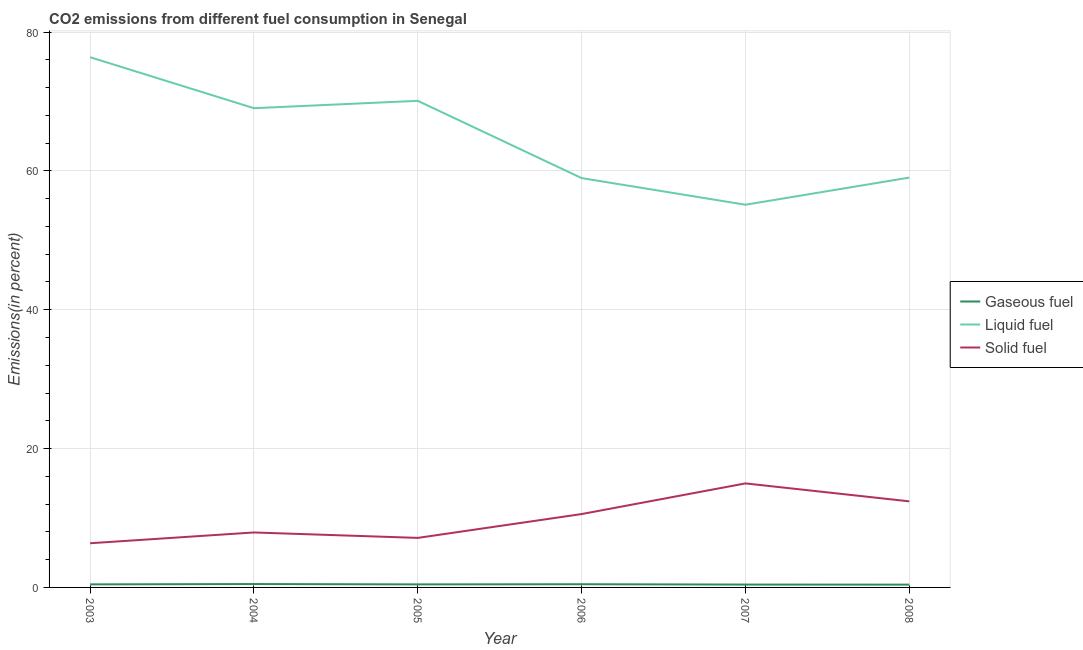Does the line corresponding to percentage of solid fuel emission intersect with the line corresponding to percentage of liquid fuel emission?
Make the answer very short. No. Is the number of lines equal to the number of legend labels?
Your answer should be compact. Yes. What is the percentage of liquid fuel emission in 2007?
Ensure brevity in your answer.  55.12. Across all years, what is the maximum percentage of liquid fuel emission?
Make the answer very short. 76.37. Across all years, what is the minimum percentage of gaseous fuel emission?
Give a very brief answer. 0.4. What is the total percentage of liquid fuel emission in the graph?
Your response must be concise. 388.6. What is the difference between the percentage of gaseous fuel emission in 2004 and that in 2006?
Offer a very short reply. 0.03. What is the difference between the percentage of liquid fuel emission in 2006 and the percentage of solid fuel emission in 2003?
Ensure brevity in your answer.  52.59. What is the average percentage of liquid fuel emission per year?
Give a very brief answer. 64.77. In the year 2006, what is the difference between the percentage of liquid fuel emission and percentage of gaseous fuel emission?
Your response must be concise. 58.5. In how many years, is the percentage of liquid fuel emission greater than 60 %?
Your answer should be compact. 3. What is the ratio of the percentage of gaseous fuel emission in 2005 to that in 2008?
Offer a terse response. 1.08. Is the percentage of gaseous fuel emission in 2004 less than that in 2007?
Your answer should be very brief. No. What is the difference between the highest and the second highest percentage of gaseous fuel emission?
Offer a very short reply. 0.03. What is the difference between the highest and the lowest percentage of liquid fuel emission?
Your response must be concise. 21.25. Are the values on the major ticks of Y-axis written in scientific E-notation?
Offer a very short reply. No. Does the graph contain grids?
Provide a short and direct response. Yes. Where does the legend appear in the graph?
Your answer should be compact. Center right. What is the title of the graph?
Ensure brevity in your answer.  CO2 emissions from different fuel consumption in Senegal. Does "Transport" appear as one of the legend labels in the graph?
Provide a short and direct response. No. What is the label or title of the Y-axis?
Keep it short and to the point. Emissions(in percent). What is the Emissions(in percent) in Gaseous fuel in 2003?
Provide a succinct answer. 0.44. What is the Emissions(in percent) in Liquid fuel in 2003?
Your answer should be compact. 76.37. What is the Emissions(in percent) of Solid fuel in 2003?
Offer a very short reply. 6.36. What is the Emissions(in percent) in Gaseous fuel in 2004?
Provide a succinct answer. 0.49. What is the Emissions(in percent) in Liquid fuel in 2004?
Provide a short and direct response. 69.03. What is the Emissions(in percent) in Solid fuel in 2004?
Make the answer very short. 7.92. What is the Emissions(in percent) in Gaseous fuel in 2005?
Your answer should be very brief. 0.44. What is the Emissions(in percent) in Liquid fuel in 2005?
Offer a terse response. 70.09. What is the Emissions(in percent) of Solid fuel in 2005?
Give a very brief answer. 7.13. What is the Emissions(in percent) of Gaseous fuel in 2006?
Keep it short and to the point. 0.46. What is the Emissions(in percent) in Liquid fuel in 2006?
Offer a terse response. 58.96. What is the Emissions(in percent) of Solid fuel in 2006?
Your answer should be very brief. 10.57. What is the Emissions(in percent) in Gaseous fuel in 2007?
Your answer should be compact. 0.41. What is the Emissions(in percent) in Liquid fuel in 2007?
Provide a short and direct response. 55.12. What is the Emissions(in percent) of Solid fuel in 2007?
Offer a terse response. 14.98. What is the Emissions(in percent) in Gaseous fuel in 2008?
Give a very brief answer. 0.4. What is the Emissions(in percent) in Liquid fuel in 2008?
Give a very brief answer. 59.03. What is the Emissions(in percent) of Solid fuel in 2008?
Your response must be concise. 12.4. Across all years, what is the maximum Emissions(in percent) of Gaseous fuel?
Your answer should be very brief. 0.49. Across all years, what is the maximum Emissions(in percent) in Liquid fuel?
Make the answer very short. 76.37. Across all years, what is the maximum Emissions(in percent) of Solid fuel?
Offer a terse response. 14.98. Across all years, what is the minimum Emissions(in percent) of Gaseous fuel?
Your response must be concise. 0.4. Across all years, what is the minimum Emissions(in percent) of Liquid fuel?
Make the answer very short. 55.12. Across all years, what is the minimum Emissions(in percent) of Solid fuel?
Your answer should be compact. 6.36. What is the total Emissions(in percent) in Gaseous fuel in the graph?
Offer a very short reply. 2.64. What is the total Emissions(in percent) of Liquid fuel in the graph?
Offer a terse response. 388.6. What is the total Emissions(in percent) in Solid fuel in the graph?
Your answer should be compact. 59.36. What is the difference between the Emissions(in percent) in Gaseous fuel in 2003 and that in 2004?
Keep it short and to the point. -0.05. What is the difference between the Emissions(in percent) of Liquid fuel in 2003 and that in 2004?
Your answer should be compact. 7.34. What is the difference between the Emissions(in percent) in Solid fuel in 2003 and that in 2004?
Offer a very short reply. -1.55. What is the difference between the Emissions(in percent) in Gaseous fuel in 2003 and that in 2005?
Give a very brief answer. 0. What is the difference between the Emissions(in percent) in Liquid fuel in 2003 and that in 2005?
Your answer should be compact. 6.28. What is the difference between the Emissions(in percent) of Solid fuel in 2003 and that in 2005?
Keep it short and to the point. -0.77. What is the difference between the Emissions(in percent) in Gaseous fuel in 2003 and that in 2006?
Keep it short and to the point. -0.02. What is the difference between the Emissions(in percent) in Liquid fuel in 2003 and that in 2006?
Keep it short and to the point. 17.41. What is the difference between the Emissions(in percent) of Solid fuel in 2003 and that in 2006?
Ensure brevity in your answer.  -4.2. What is the difference between the Emissions(in percent) in Gaseous fuel in 2003 and that in 2007?
Your response must be concise. 0.03. What is the difference between the Emissions(in percent) in Liquid fuel in 2003 and that in 2007?
Your answer should be very brief. 21.25. What is the difference between the Emissions(in percent) in Solid fuel in 2003 and that in 2007?
Give a very brief answer. -8.62. What is the difference between the Emissions(in percent) in Gaseous fuel in 2003 and that in 2008?
Ensure brevity in your answer.  0.03. What is the difference between the Emissions(in percent) of Liquid fuel in 2003 and that in 2008?
Your answer should be very brief. 17.34. What is the difference between the Emissions(in percent) in Solid fuel in 2003 and that in 2008?
Provide a succinct answer. -6.03. What is the difference between the Emissions(in percent) in Gaseous fuel in 2004 and that in 2005?
Offer a terse response. 0.05. What is the difference between the Emissions(in percent) of Liquid fuel in 2004 and that in 2005?
Give a very brief answer. -1.06. What is the difference between the Emissions(in percent) in Solid fuel in 2004 and that in 2005?
Offer a terse response. 0.78. What is the difference between the Emissions(in percent) in Gaseous fuel in 2004 and that in 2006?
Your answer should be compact. 0.03. What is the difference between the Emissions(in percent) of Liquid fuel in 2004 and that in 2006?
Provide a short and direct response. 10.07. What is the difference between the Emissions(in percent) of Solid fuel in 2004 and that in 2006?
Provide a short and direct response. -2.65. What is the difference between the Emissions(in percent) in Gaseous fuel in 2004 and that in 2007?
Provide a short and direct response. 0.07. What is the difference between the Emissions(in percent) in Liquid fuel in 2004 and that in 2007?
Your response must be concise. 13.91. What is the difference between the Emissions(in percent) in Solid fuel in 2004 and that in 2007?
Give a very brief answer. -7.07. What is the difference between the Emissions(in percent) of Gaseous fuel in 2004 and that in 2008?
Keep it short and to the point. 0.08. What is the difference between the Emissions(in percent) of Liquid fuel in 2004 and that in 2008?
Your response must be concise. 10. What is the difference between the Emissions(in percent) in Solid fuel in 2004 and that in 2008?
Offer a terse response. -4.48. What is the difference between the Emissions(in percent) in Gaseous fuel in 2005 and that in 2006?
Provide a short and direct response. -0.02. What is the difference between the Emissions(in percent) of Liquid fuel in 2005 and that in 2006?
Provide a short and direct response. 11.13. What is the difference between the Emissions(in percent) in Solid fuel in 2005 and that in 2006?
Offer a terse response. -3.43. What is the difference between the Emissions(in percent) in Gaseous fuel in 2005 and that in 2007?
Offer a very short reply. 0.03. What is the difference between the Emissions(in percent) in Liquid fuel in 2005 and that in 2007?
Give a very brief answer. 14.97. What is the difference between the Emissions(in percent) in Solid fuel in 2005 and that in 2007?
Give a very brief answer. -7.85. What is the difference between the Emissions(in percent) of Gaseous fuel in 2005 and that in 2008?
Your answer should be very brief. 0.03. What is the difference between the Emissions(in percent) in Liquid fuel in 2005 and that in 2008?
Ensure brevity in your answer.  11.06. What is the difference between the Emissions(in percent) in Solid fuel in 2005 and that in 2008?
Your response must be concise. -5.26. What is the difference between the Emissions(in percent) in Gaseous fuel in 2006 and that in 2007?
Your response must be concise. 0.05. What is the difference between the Emissions(in percent) of Liquid fuel in 2006 and that in 2007?
Your answer should be very brief. 3.84. What is the difference between the Emissions(in percent) in Solid fuel in 2006 and that in 2007?
Keep it short and to the point. -4.42. What is the difference between the Emissions(in percent) of Gaseous fuel in 2006 and that in 2008?
Provide a succinct answer. 0.06. What is the difference between the Emissions(in percent) of Liquid fuel in 2006 and that in 2008?
Ensure brevity in your answer.  -0.07. What is the difference between the Emissions(in percent) of Solid fuel in 2006 and that in 2008?
Keep it short and to the point. -1.83. What is the difference between the Emissions(in percent) of Gaseous fuel in 2007 and that in 2008?
Provide a succinct answer. 0.01. What is the difference between the Emissions(in percent) in Liquid fuel in 2007 and that in 2008?
Your response must be concise. -3.91. What is the difference between the Emissions(in percent) of Solid fuel in 2007 and that in 2008?
Provide a succinct answer. 2.58. What is the difference between the Emissions(in percent) of Gaseous fuel in 2003 and the Emissions(in percent) of Liquid fuel in 2004?
Ensure brevity in your answer.  -68.59. What is the difference between the Emissions(in percent) of Gaseous fuel in 2003 and the Emissions(in percent) of Solid fuel in 2004?
Your answer should be compact. -7.48. What is the difference between the Emissions(in percent) in Liquid fuel in 2003 and the Emissions(in percent) in Solid fuel in 2004?
Give a very brief answer. 68.45. What is the difference between the Emissions(in percent) of Gaseous fuel in 2003 and the Emissions(in percent) of Liquid fuel in 2005?
Your answer should be very brief. -69.65. What is the difference between the Emissions(in percent) in Gaseous fuel in 2003 and the Emissions(in percent) in Solid fuel in 2005?
Provide a succinct answer. -6.7. What is the difference between the Emissions(in percent) of Liquid fuel in 2003 and the Emissions(in percent) of Solid fuel in 2005?
Ensure brevity in your answer.  69.24. What is the difference between the Emissions(in percent) of Gaseous fuel in 2003 and the Emissions(in percent) of Liquid fuel in 2006?
Provide a short and direct response. -58.52. What is the difference between the Emissions(in percent) in Gaseous fuel in 2003 and the Emissions(in percent) in Solid fuel in 2006?
Keep it short and to the point. -10.13. What is the difference between the Emissions(in percent) in Liquid fuel in 2003 and the Emissions(in percent) in Solid fuel in 2006?
Provide a short and direct response. 65.81. What is the difference between the Emissions(in percent) of Gaseous fuel in 2003 and the Emissions(in percent) of Liquid fuel in 2007?
Ensure brevity in your answer.  -54.68. What is the difference between the Emissions(in percent) of Gaseous fuel in 2003 and the Emissions(in percent) of Solid fuel in 2007?
Your answer should be very brief. -14.54. What is the difference between the Emissions(in percent) in Liquid fuel in 2003 and the Emissions(in percent) in Solid fuel in 2007?
Offer a terse response. 61.39. What is the difference between the Emissions(in percent) of Gaseous fuel in 2003 and the Emissions(in percent) of Liquid fuel in 2008?
Your answer should be compact. -58.59. What is the difference between the Emissions(in percent) in Gaseous fuel in 2003 and the Emissions(in percent) in Solid fuel in 2008?
Make the answer very short. -11.96. What is the difference between the Emissions(in percent) in Liquid fuel in 2003 and the Emissions(in percent) in Solid fuel in 2008?
Ensure brevity in your answer.  63.97. What is the difference between the Emissions(in percent) in Gaseous fuel in 2004 and the Emissions(in percent) in Liquid fuel in 2005?
Your response must be concise. -69.6. What is the difference between the Emissions(in percent) of Gaseous fuel in 2004 and the Emissions(in percent) of Solid fuel in 2005?
Your answer should be compact. -6.65. What is the difference between the Emissions(in percent) in Liquid fuel in 2004 and the Emissions(in percent) in Solid fuel in 2005?
Your answer should be compact. 61.89. What is the difference between the Emissions(in percent) of Gaseous fuel in 2004 and the Emissions(in percent) of Liquid fuel in 2006?
Provide a short and direct response. -58.47. What is the difference between the Emissions(in percent) in Gaseous fuel in 2004 and the Emissions(in percent) in Solid fuel in 2006?
Your response must be concise. -10.08. What is the difference between the Emissions(in percent) of Liquid fuel in 2004 and the Emissions(in percent) of Solid fuel in 2006?
Provide a succinct answer. 58.46. What is the difference between the Emissions(in percent) of Gaseous fuel in 2004 and the Emissions(in percent) of Liquid fuel in 2007?
Your answer should be very brief. -54.63. What is the difference between the Emissions(in percent) of Gaseous fuel in 2004 and the Emissions(in percent) of Solid fuel in 2007?
Provide a short and direct response. -14.5. What is the difference between the Emissions(in percent) of Liquid fuel in 2004 and the Emissions(in percent) of Solid fuel in 2007?
Ensure brevity in your answer.  54.05. What is the difference between the Emissions(in percent) in Gaseous fuel in 2004 and the Emissions(in percent) in Liquid fuel in 2008?
Keep it short and to the point. -58.54. What is the difference between the Emissions(in percent) in Gaseous fuel in 2004 and the Emissions(in percent) in Solid fuel in 2008?
Offer a very short reply. -11.91. What is the difference between the Emissions(in percent) in Liquid fuel in 2004 and the Emissions(in percent) in Solid fuel in 2008?
Ensure brevity in your answer.  56.63. What is the difference between the Emissions(in percent) of Gaseous fuel in 2005 and the Emissions(in percent) of Liquid fuel in 2006?
Keep it short and to the point. -58.52. What is the difference between the Emissions(in percent) in Gaseous fuel in 2005 and the Emissions(in percent) in Solid fuel in 2006?
Your response must be concise. -10.13. What is the difference between the Emissions(in percent) in Liquid fuel in 2005 and the Emissions(in percent) in Solid fuel in 2006?
Your answer should be compact. 59.52. What is the difference between the Emissions(in percent) in Gaseous fuel in 2005 and the Emissions(in percent) in Liquid fuel in 2007?
Give a very brief answer. -54.68. What is the difference between the Emissions(in percent) in Gaseous fuel in 2005 and the Emissions(in percent) in Solid fuel in 2007?
Your answer should be compact. -14.54. What is the difference between the Emissions(in percent) of Liquid fuel in 2005 and the Emissions(in percent) of Solid fuel in 2007?
Provide a succinct answer. 55.1. What is the difference between the Emissions(in percent) in Gaseous fuel in 2005 and the Emissions(in percent) in Liquid fuel in 2008?
Keep it short and to the point. -58.59. What is the difference between the Emissions(in percent) of Gaseous fuel in 2005 and the Emissions(in percent) of Solid fuel in 2008?
Your answer should be compact. -11.96. What is the difference between the Emissions(in percent) in Liquid fuel in 2005 and the Emissions(in percent) in Solid fuel in 2008?
Your answer should be compact. 57.69. What is the difference between the Emissions(in percent) in Gaseous fuel in 2006 and the Emissions(in percent) in Liquid fuel in 2007?
Your answer should be very brief. -54.66. What is the difference between the Emissions(in percent) of Gaseous fuel in 2006 and the Emissions(in percent) of Solid fuel in 2007?
Your answer should be very brief. -14.52. What is the difference between the Emissions(in percent) of Liquid fuel in 2006 and the Emissions(in percent) of Solid fuel in 2007?
Give a very brief answer. 43.98. What is the difference between the Emissions(in percent) in Gaseous fuel in 2006 and the Emissions(in percent) in Liquid fuel in 2008?
Give a very brief answer. -58.57. What is the difference between the Emissions(in percent) in Gaseous fuel in 2006 and the Emissions(in percent) in Solid fuel in 2008?
Your response must be concise. -11.94. What is the difference between the Emissions(in percent) in Liquid fuel in 2006 and the Emissions(in percent) in Solid fuel in 2008?
Provide a succinct answer. 46.56. What is the difference between the Emissions(in percent) in Gaseous fuel in 2007 and the Emissions(in percent) in Liquid fuel in 2008?
Offer a very short reply. -58.62. What is the difference between the Emissions(in percent) of Gaseous fuel in 2007 and the Emissions(in percent) of Solid fuel in 2008?
Your response must be concise. -11.99. What is the difference between the Emissions(in percent) of Liquid fuel in 2007 and the Emissions(in percent) of Solid fuel in 2008?
Offer a very short reply. 42.72. What is the average Emissions(in percent) in Gaseous fuel per year?
Offer a very short reply. 0.44. What is the average Emissions(in percent) of Liquid fuel per year?
Give a very brief answer. 64.77. What is the average Emissions(in percent) of Solid fuel per year?
Keep it short and to the point. 9.89. In the year 2003, what is the difference between the Emissions(in percent) of Gaseous fuel and Emissions(in percent) of Liquid fuel?
Make the answer very short. -75.93. In the year 2003, what is the difference between the Emissions(in percent) of Gaseous fuel and Emissions(in percent) of Solid fuel?
Keep it short and to the point. -5.93. In the year 2003, what is the difference between the Emissions(in percent) of Liquid fuel and Emissions(in percent) of Solid fuel?
Provide a short and direct response. 70.01. In the year 2004, what is the difference between the Emissions(in percent) of Gaseous fuel and Emissions(in percent) of Liquid fuel?
Your answer should be very brief. -68.54. In the year 2004, what is the difference between the Emissions(in percent) of Gaseous fuel and Emissions(in percent) of Solid fuel?
Provide a short and direct response. -7.43. In the year 2004, what is the difference between the Emissions(in percent) in Liquid fuel and Emissions(in percent) in Solid fuel?
Your answer should be very brief. 61.11. In the year 2005, what is the difference between the Emissions(in percent) in Gaseous fuel and Emissions(in percent) in Liquid fuel?
Ensure brevity in your answer.  -69.65. In the year 2005, what is the difference between the Emissions(in percent) in Gaseous fuel and Emissions(in percent) in Solid fuel?
Your answer should be very brief. -6.7. In the year 2005, what is the difference between the Emissions(in percent) in Liquid fuel and Emissions(in percent) in Solid fuel?
Make the answer very short. 62.95. In the year 2006, what is the difference between the Emissions(in percent) of Gaseous fuel and Emissions(in percent) of Liquid fuel?
Keep it short and to the point. -58.5. In the year 2006, what is the difference between the Emissions(in percent) of Gaseous fuel and Emissions(in percent) of Solid fuel?
Keep it short and to the point. -10.11. In the year 2006, what is the difference between the Emissions(in percent) in Liquid fuel and Emissions(in percent) in Solid fuel?
Make the answer very short. 48.39. In the year 2007, what is the difference between the Emissions(in percent) in Gaseous fuel and Emissions(in percent) in Liquid fuel?
Your answer should be very brief. -54.71. In the year 2007, what is the difference between the Emissions(in percent) in Gaseous fuel and Emissions(in percent) in Solid fuel?
Your answer should be very brief. -14.57. In the year 2007, what is the difference between the Emissions(in percent) in Liquid fuel and Emissions(in percent) in Solid fuel?
Give a very brief answer. 40.14. In the year 2008, what is the difference between the Emissions(in percent) in Gaseous fuel and Emissions(in percent) in Liquid fuel?
Your answer should be very brief. -58.63. In the year 2008, what is the difference between the Emissions(in percent) of Gaseous fuel and Emissions(in percent) of Solid fuel?
Provide a short and direct response. -11.99. In the year 2008, what is the difference between the Emissions(in percent) in Liquid fuel and Emissions(in percent) in Solid fuel?
Offer a terse response. 46.63. What is the ratio of the Emissions(in percent) in Gaseous fuel in 2003 to that in 2004?
Offer a very short reply. 0.9. What is the ratio of the Emissions(in percent) in Liquid fuel in 2003 to that in 2004?
Your answer should be compact. 1.11. What is the ratio of the Emissions(in percent) in Solid fuel in 2003 to that in 2004?
Make the answer very short. 0.8. What is the ratio of the Emissions(in percent) of Liquid fuel in 2003 to that in 2005?
Your answer should be very brief. 1.09. What is the ratio of the Emissions(in percent) in Solid fuel in 2003 to that in 2005?
Your answer should be compact. 0.89. What is the ratio of the Emissions(in percent) in Gaseous fuel in 2003 to that in 2006?
Offer a very short reply. 0.96. What is the ratio of the Emissions(in percent) in Liquid fuel in 2003 to that in 2006?
Your answer should be very brief. 1.3. What is the ratio of the Emissions(in percent) in Solid fuel in 2003 to that in 2006?
Your response must be concise. 0.6. What is the ratio of the Emissions(in percent) in Gaseous fuel in 2003 to that in 2007?
Your response must be concise. 1.06. What is the ratio of the Emissions(in percent) in Liquid fuel in 2003 to that in 2007?
Keep it short and to the point. 1.39. What is the ratio of the Emissions(in percent) in Solid fuel in 2003 to that in 2007?
Offer a terse response. 0.42. What is the ratio of the Emissions(in percent) of Gaseous fuel in 2003 to that in 2008?
Your answer should be very brief. 1.09. What is the ratio of the Emissions(in percent) in Liquid fuel in 2003 to that in 2008?
Give a very brief answer. 1.29. What is the ratio of the Emissions(in percent) in Solid fuel in 2003 to that in 2008?
Provide a short and direct response. 0.51. What is the ratio of the Emissions(in percent) in Gaseous fuel in 2004 to that in 2005?
Your response must be concise. 1.11. What is the ratio of the Emissions(in percent) in Liquid fuel in 2004 to that in 2005?
Keep it short and to the point. 0.98. What is the ratio of the Emissions(in percent) in Solid fuel in 2004 to that in 2005?
Ensure brevity in your answer.  1.11. What is the ratio of the Emissions(in percent) in Gaseous fuel in 2004 to that in 2006?
Give a very brief answer. 1.06. What is the ratio of the Emissions(in percent) in Liquid fuel in 2004 to that in 2006?
Make the answer very short. 1.17. What is the ratio of the Emissions(in percent) in Solid fuel in 2004 to that in 2006?
Your response must be concise. 0.75. What is the ratio of the Emissions(in percent) in Gaseous fuel in 2004 to that in 2007?
Your answer should be very brief. 1.18. What is the ratio of the Emissions(in percent) in Liquid fuel in 2004 to that in 2007?
Keep it short and to the point. 1.25. What is the ratio of the Emissions(in percent) in Solid fuel in 2004 to that in 2007?
Offer a terse response. 0.53. What is the ratio of the Emissions(in percent) in Gaseous fuel in 2004 to that in 2008?
Make the answer very short. 1.2. What is the ratio of the Emissions(in percent) in Liquid fuel in 2004 to that in 2008?
Keep it short and to the point. 1.17. What is the ratio of the Emissions(in percent) in Solid fuel in 2004 to that in 2008?
Offer a very short reply. 0.64. What is the ratio of the Emissions(in percent) in Gaseous fuel in 2005 to that in 2006?
Give a very brief answer. 0.95. What is the ratio of the Emissions(in percent) in Liquid fuel in 2005 to that in 2006?
Offer a terse response. 1.19. What is the ratio of the Emissions(in percent) of Solid fuel in 2005 to that in 2006?
Provide a short and direct response. 0.68. What is the ratio of the Emissions(in percent) of Gaseous fuel in 2005 to that in 2007?
Give a very brief answer. 1.06. What is the ratio of the Emissions(in percent) of Liquid fuel in 2005 to that in 2007?
Provide a succinct answer. 1.27. What is the ratio of the Emissions(in percent) in Solid fuel in 2005 to that in 2007?
Offer a very short reply. 0.48. What is the ratio of the Emissions(in percent) in Gaseous fuel in 2005 to that in 2008?
Provide a short and direct response. 1.08. What is the ratio of the Emissions(in percent) of Liquid fuel in 2005 to that in 2008?
Provide a succinct answer. 1.19. What is the ratio of the Emissions(in percent) in Solid fuel in 2005 to that in 2008?
Give a very brief answer. 0.58. What is the ratio of the Emissions(in percent) of Gaseous fuel in 2006 to that in 2007?
Provide a succinct answer. 1.11. What is the ratio of the Emissions(in percent) of Liquid fuel in 2006 to that in 2007?
Give a very brief answer. 1.07. What is the ratio of the Emissions(in percent) of Solid fuel in 2006 to that in 2007?
Your answer should be very brief. 0.71. What is the ratio of the Emissions(in percent) of Gaseous fuel in 2006 to that in 2008?
Your response must be concise. 1.14. What is the ratio of the Emissions(in percent) of Liquid fuel in 2006 to that in 2008?
Your answer should be compact. 1. What is the ratio of the Emissions(in percent) in Solid fuel in 2006 to that in 2008?
Make the answer very short. 0.85. What is the ratio of the Emissions(in percent) of Gaseous fuel in 2007 to that in 2008?
Your answer should be compact. 1.02. What is the ratio of the Emissions(in percent) of Liquid fuel in 2007 to that in 2008?
Make the answer very short. 0.93. What is the ratio of the Emissions(in percent) in Solid fuel in 2007 to that in 2008?
Keep it short and to the point. 1.21. What is the difference between the highest and the second highest Emissions(in percent) in Gaseous fuel?
Offer a terse response. 0.03. What is the difference between the highest and the second highest Emissions(in percent) of Liquid fuel?
Keep it short and to the point. 6.28. What is the difference between the highest and the second highest Emissions(in percent) in Solid fuel?
Make the answer very short. 2.58. What is the difference between the highest and the lowest Emissions(in percent) in Gaseous fuel?
Give a very brief answer. 0.08. What is the difference between the highest and the lowest Emissions(in percent) in Liquid fuel?
Your answer should be compact. 21.25. What is the difference between the highest and the lowest Emissions(in percent) of Solid fuel?
Ensure brevity in your answer.  8.62. 